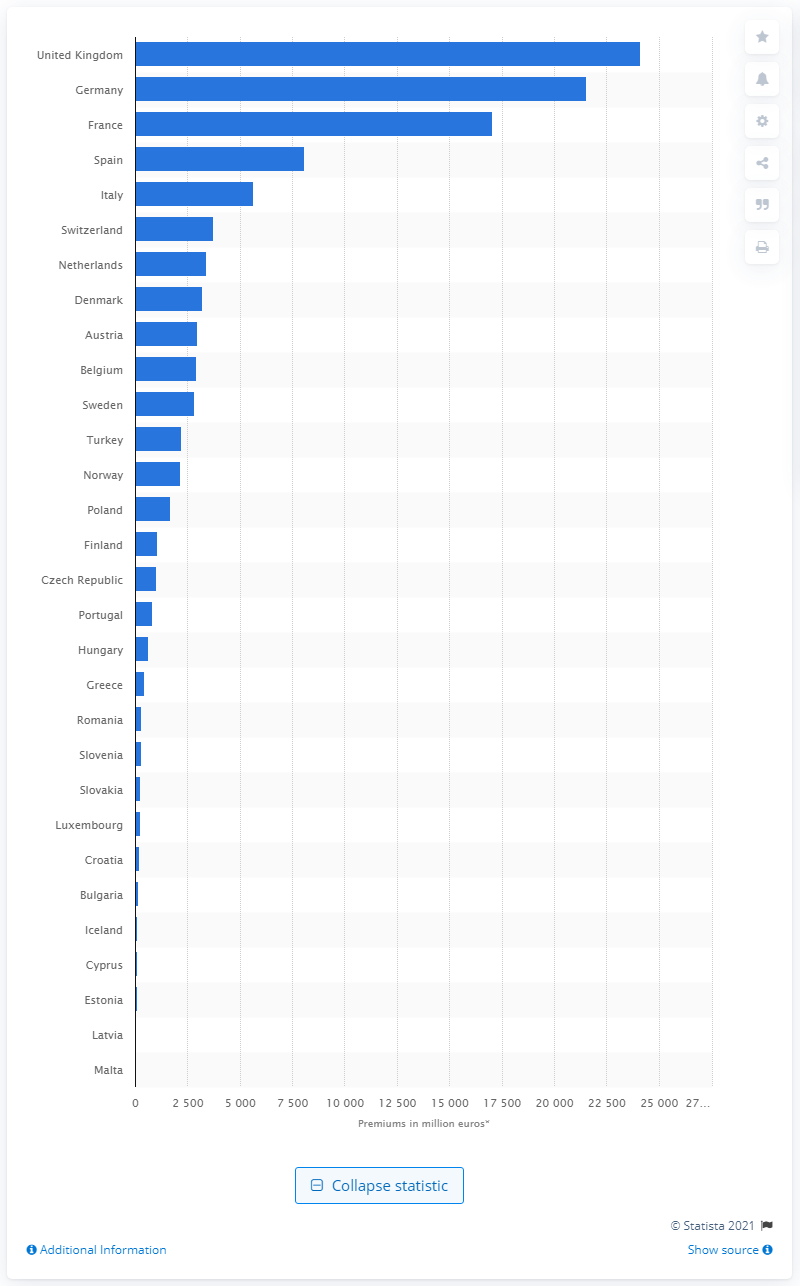Identify some key points in this picture. According to data from 2019, the United Kingdom spent a significant amount of money on property insurance premiums. 